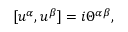Convert formula to latex. <formula><loc_0><loc_0><loc_500><loc_500>[ u ^ { \alpha } , u ^ { \beta } ] = i \Theta ^ { \alpha \beta } ,</formula> 